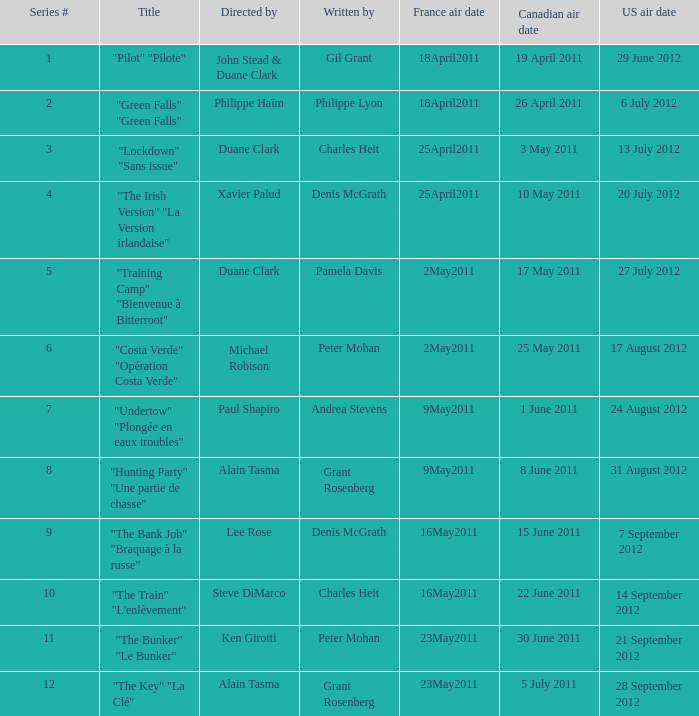What is the canadian air date when the US air date is 24 august 2012? 1 June 2011. 